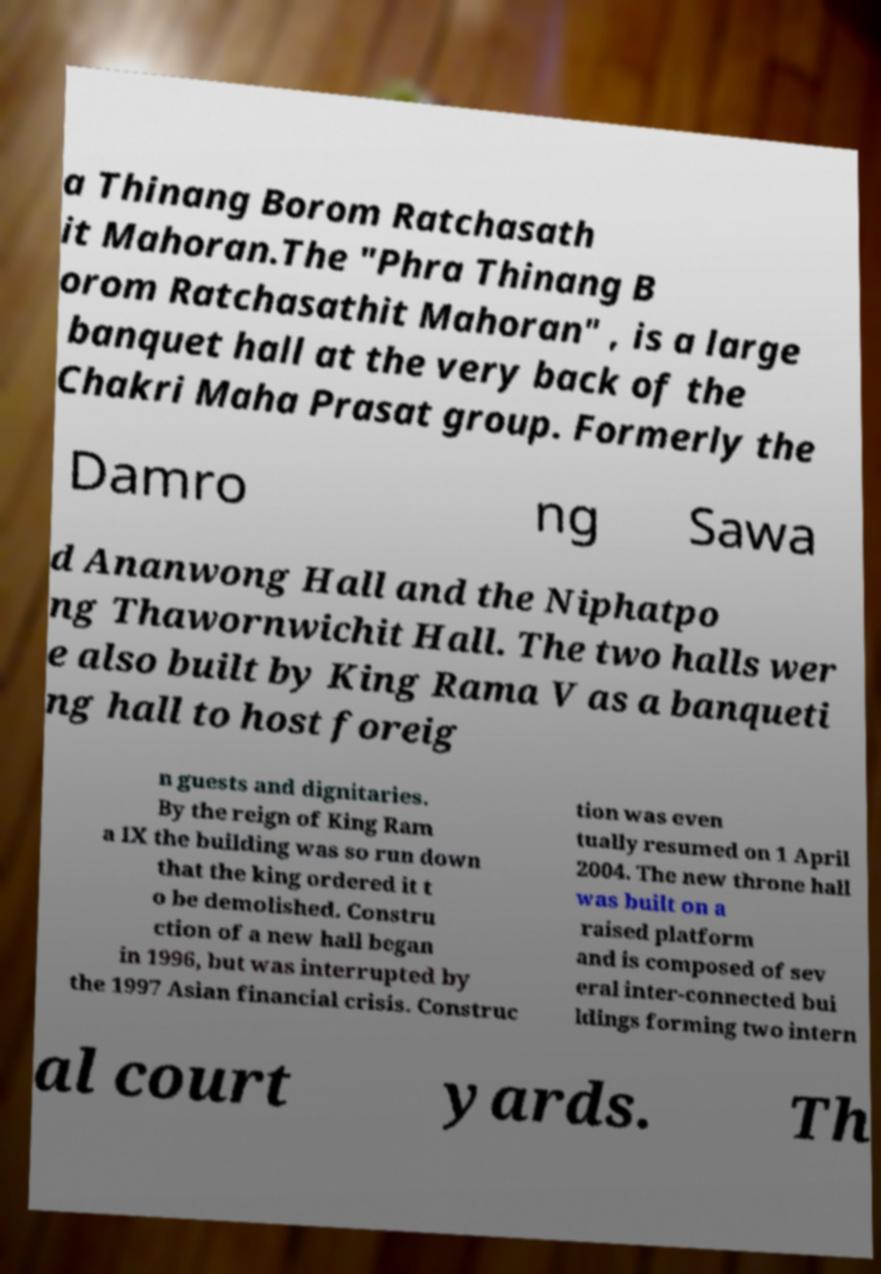I need the written content from this picture converted into text. Can you do that? a Thinang Borom Ratchasath it Mahoran.The "Phra Thinang B orom Ratchasathit Mahoran" , is a large banquet hall at the very back of the Chakri Maha Prasat group. Formerly the Damro ng Sawa d Ananwong Hall and the Niphatpo ng Thawornwichit Hall. The two halls wer e also built by King Rama V as a banqueti ng hall to host foreig n guests and dignitaries. By the reign of King Ram a IX the building was so run down that the king ordered it t o be demolished. Constru ction of a new hall began in 1996, but was interrupted by the 1997 Asian financial crisis. Construc tion was even tually resumed on 1 April 2004. The new throne hall was built on a raised platform and is composed of sev eral inter-connected bui ldings forming two intern al court yards. Th 